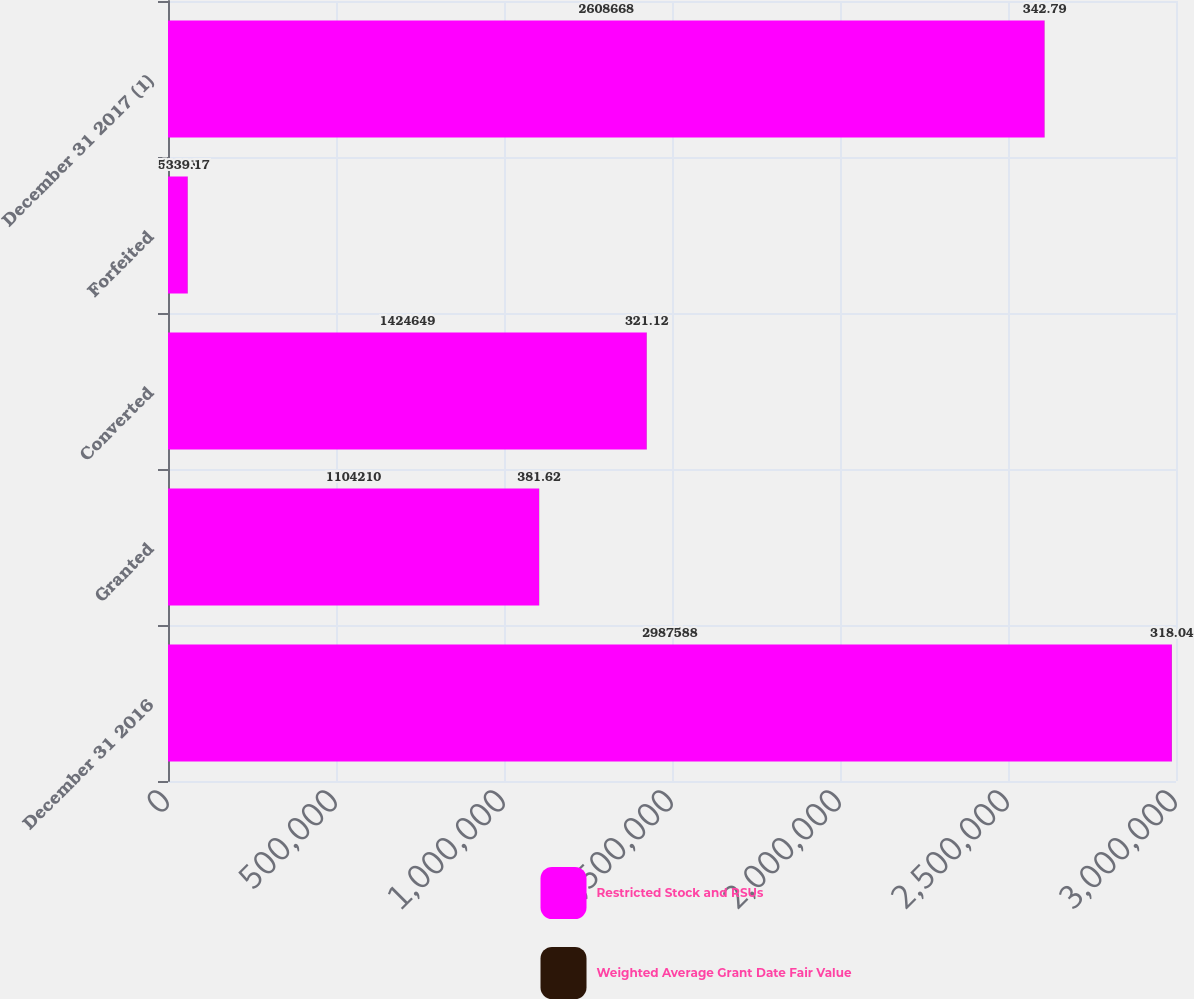<chart> <loc_0><loc_0><loc_500><loc_500><stacked_bar_chart><ecel><fcel>December 31 2016<fcel>Granted<fcel>Converted<fcel>Forfeited<fcel>December 31 2017 (1)<nl><fcel>Restricted Stock and RSUs<fcel>2.98759e+06<fcel>1.10421e+06<fcel>1.42465e+06<fcel>58481<fcel>2.60867e+06<nl><fcel>Weighted Average Grant Date Fair Value<fcel>318.04<fcel>381.62<fcel>321.12<fcel>339.17<fcel>342.79<nl></chart> 